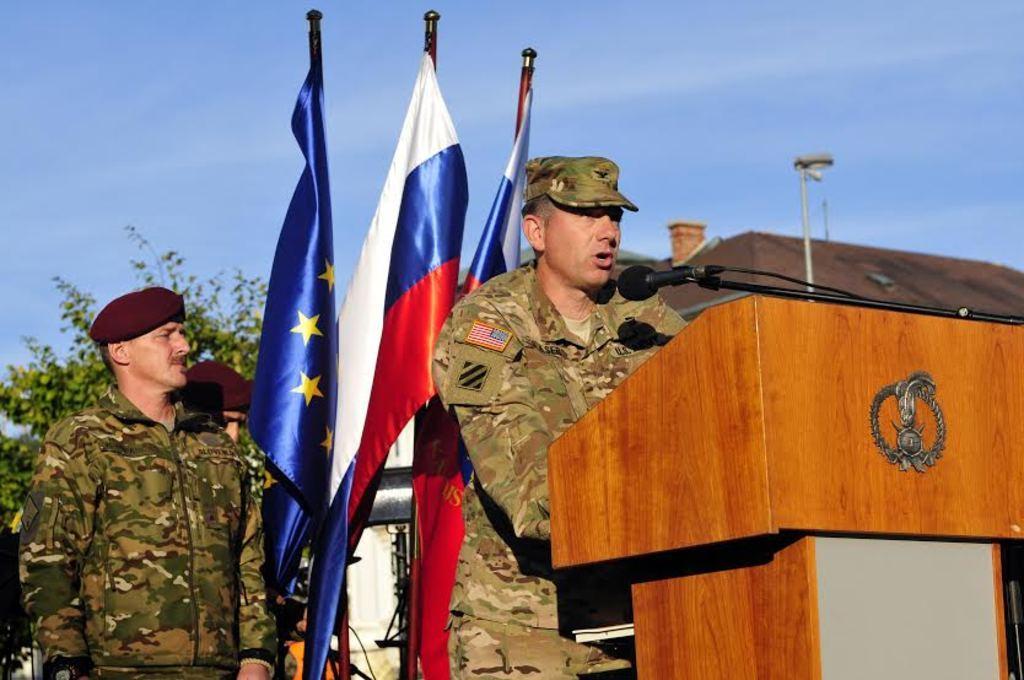How would you summarize this image in a sentence or two? In the center of the image there is a person standing at the desk. On the desk we can see mic. On the left side of the image we can see flags and persons. In the background we can see building, trees and sky. 